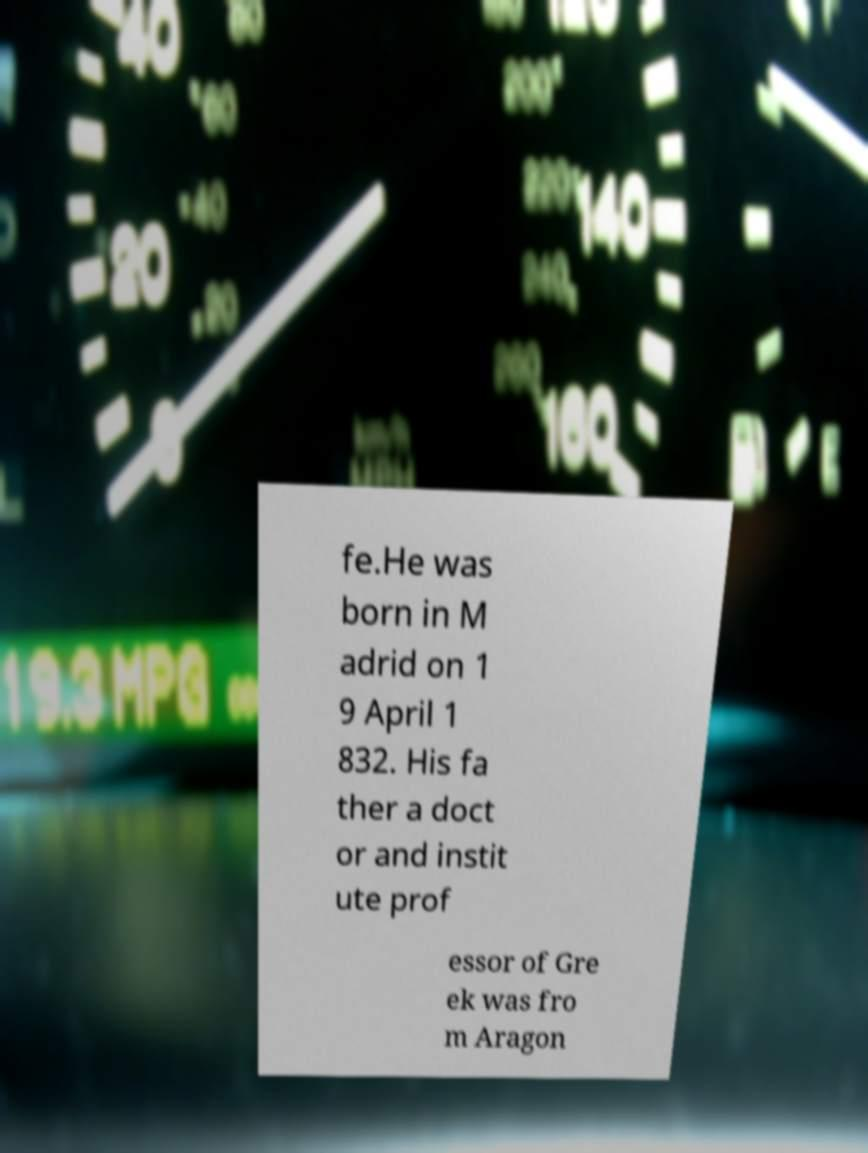Could you extract and type out the text from this image? fe.He was born in M adrid on 1 9 April 1 832. His fa ther a doct or and instit ute prof essor of Gre ek was fro m Aragon 